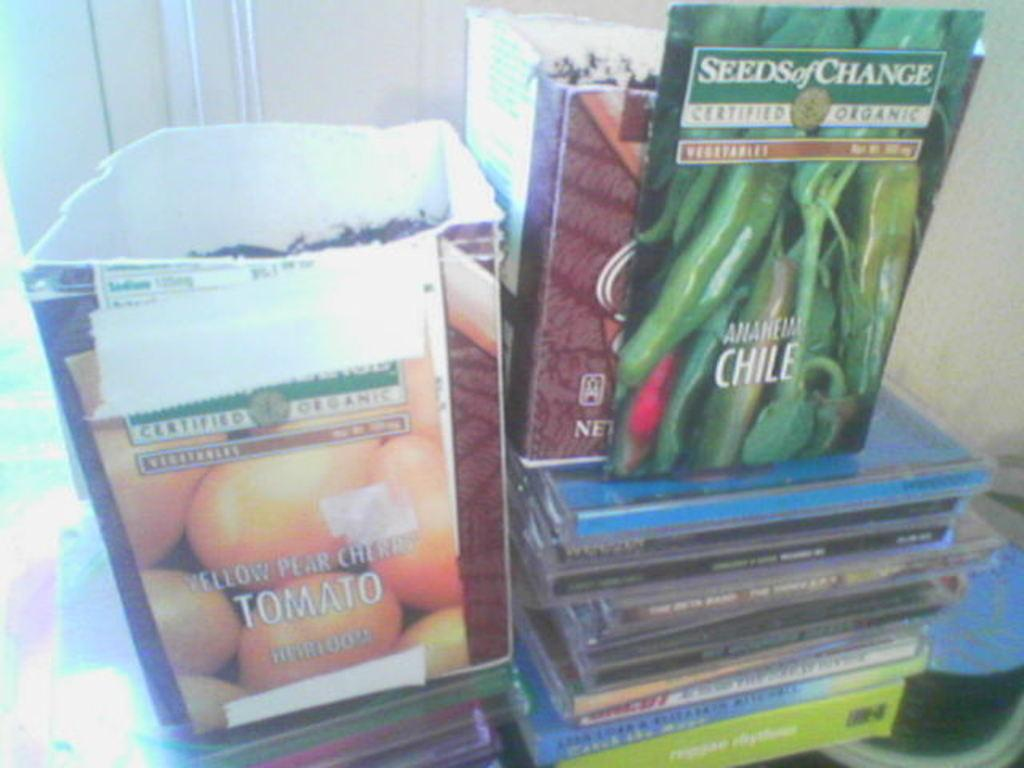What type of objects can be seen in the image? There are small cardboard boxes, a packet, and CD boxes in the image. Where is the packet located in the image? The packet is in the center of the image. What might be the purpose of the small cardboard boxes in the image? The small cardboard boxes might be used for packaging or storage. Can you describe the CD boxes in the image? The CD boxes are located at the bottom side of the image. What grade is the teacher giving to the scene in the image? There is no scene or teacher present in the image, so it is not possible to determine a grade. 